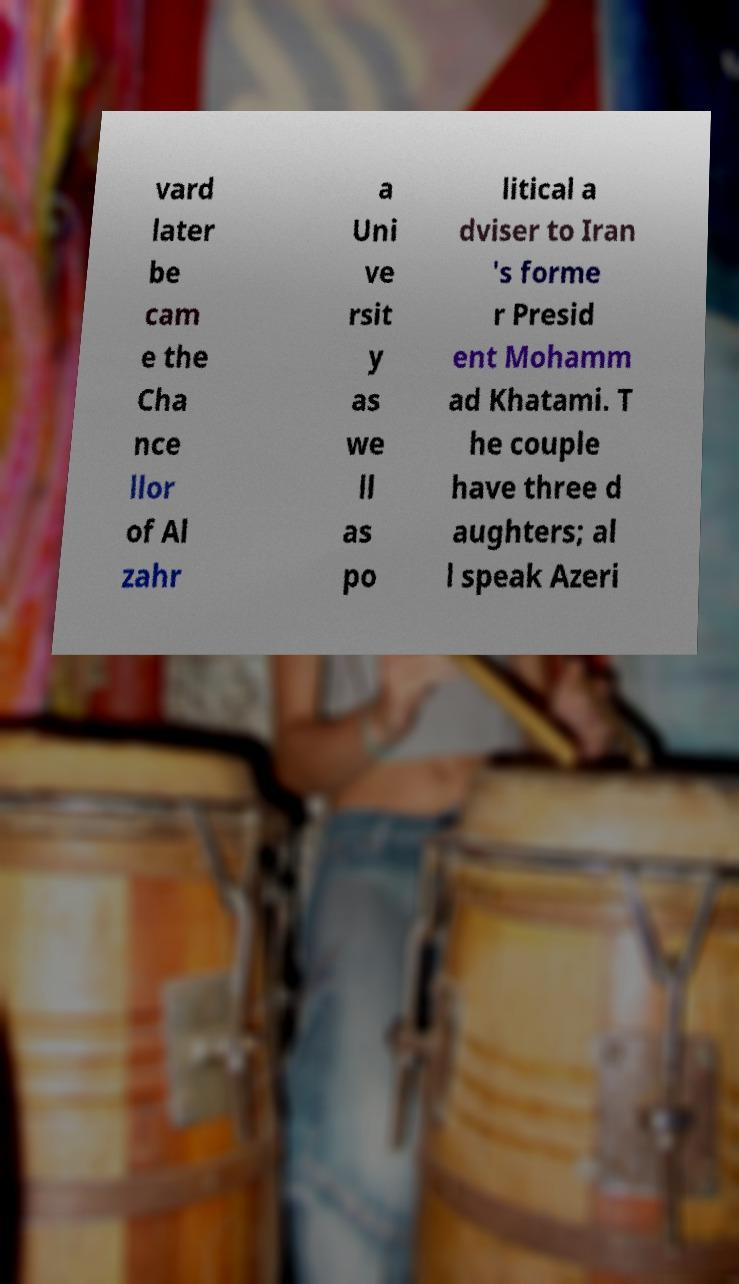What messages or text are displayed in this image? I need them in a readable, typed format. vard later be cam e the Cha nce llor of Al zahr a Uni ve rsit y as we ll as po litical a dviser to Iran 's forme r Presid ent Mohamm ad Khatami. T he couple have three d aughters; al l speak Azeri 